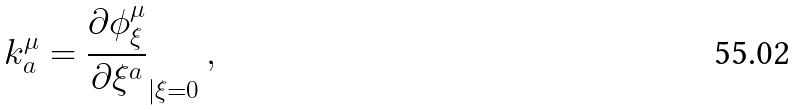Convert formula to latex. <formula><loc_0><loc_0><loc_500><loc_500>k _ { a } ^ { \mu } = { \frac { \partial \phi ^ { \mu } _ { \xi } } { \partial \xi ^ { a } } } _ { | \xi = 0 } \, ,</formula> 